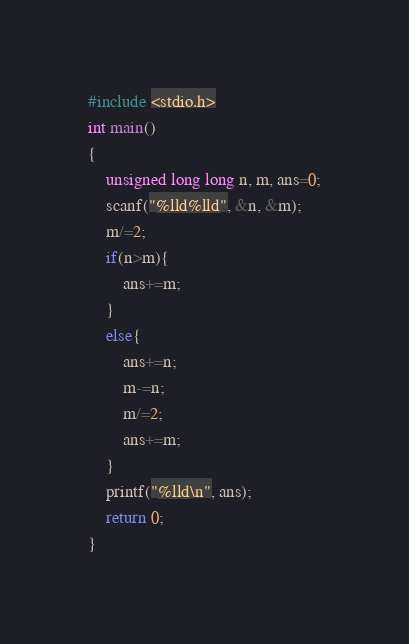<code> <loc_0><loc_0><loc_500><loc_500><_C_>#include <stdio.h>
int main()
{
	unsigned long long n, m, ans=0;
	scanf("%lld%lld", &n, &m);
	m/=2;
	if(n>m){
		ans+=m;
	}
	else{
		ans+=n;
		m-=n;
		m/=2;
		ans+=m;
	}
	printf("%lld\n", ans);
	return 0;
}</code> 